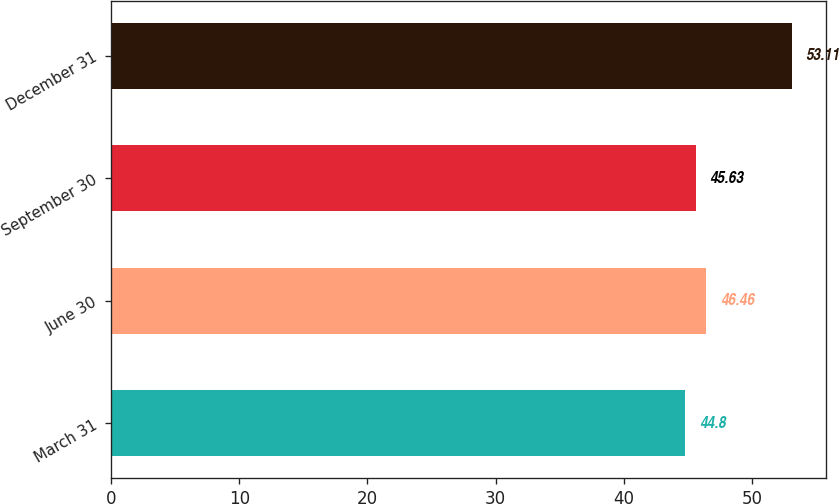<chart> <loc_0><loc_0><loc_500><loc_500><bar_chart><fcel>March 31<fcel>June 30<fcel>September 30<fcel>December 31<nl><fcel>44.8<fcel>46.46<fcel>45.63<fcel>53.11<nl></chart> 